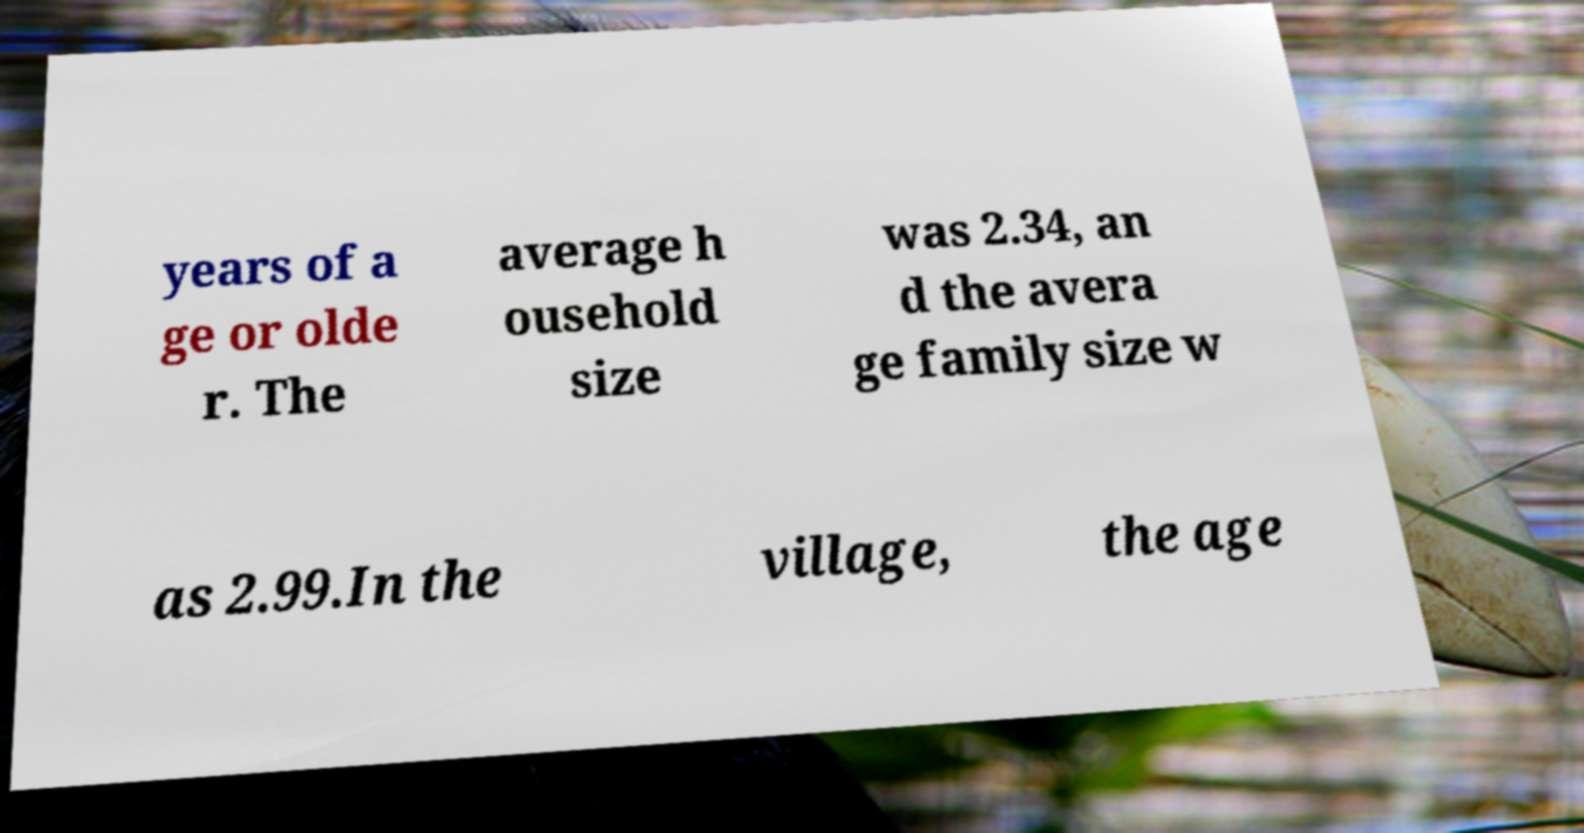Please identify and transcribe the text found in this image. years of a ge or olde r. The average h ousehold size was 2.34, an d the avera ge family size w as 2.99.In the village, the age 